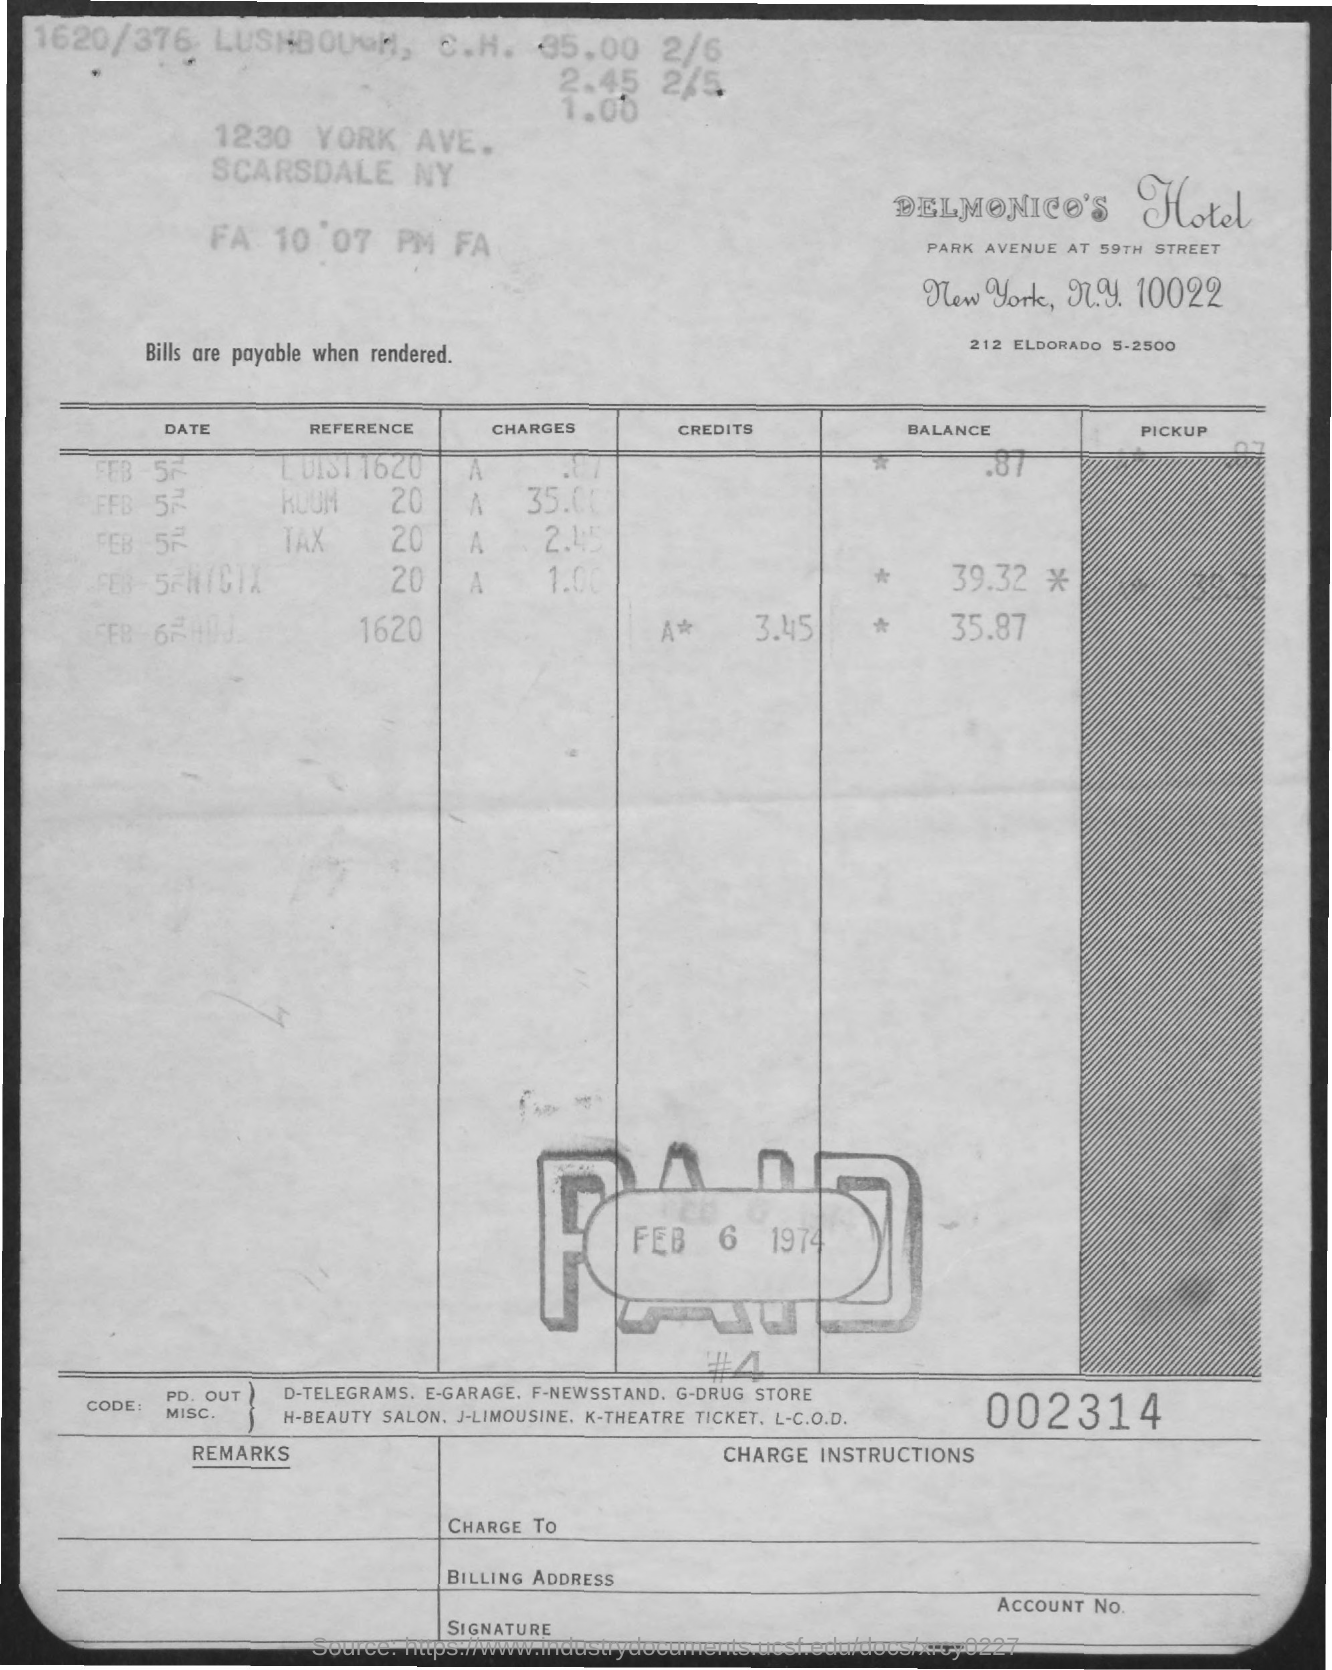Indicate a few pertinent items in this graphic. The number at the bottom of the document is a 6-digit number, which is 002314.. The date of the pay is February 6th, 1974. Delmonico's Hotel is the name of the hotel. 